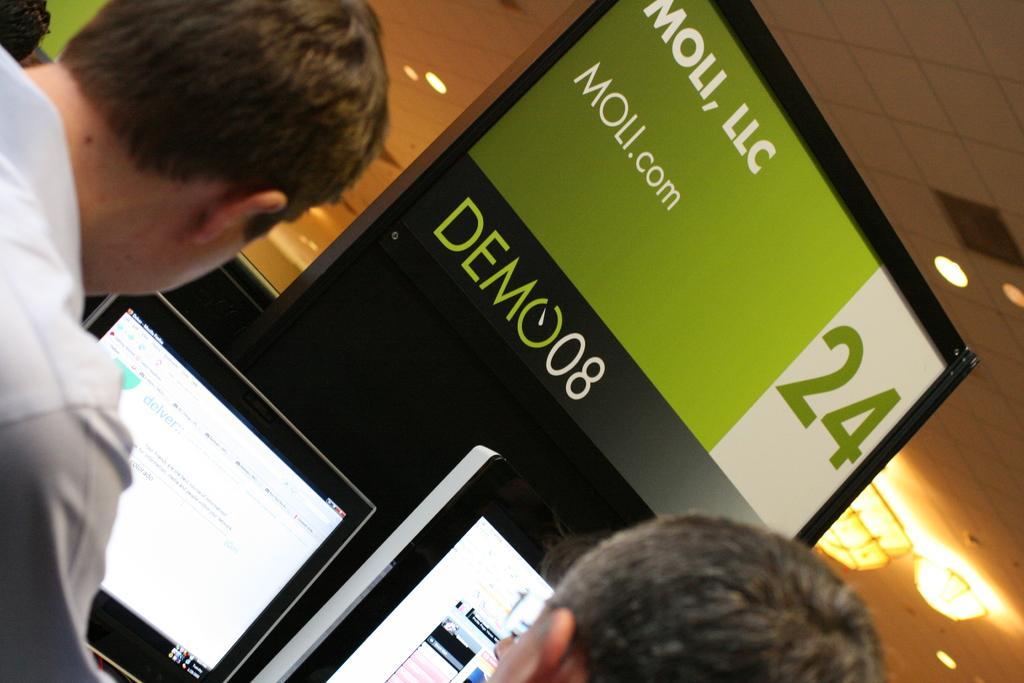Describe this image in one or two sentences. There are people. In front of them there are computers. Also there is a board with something written. Also there are lights on the ceiling. 